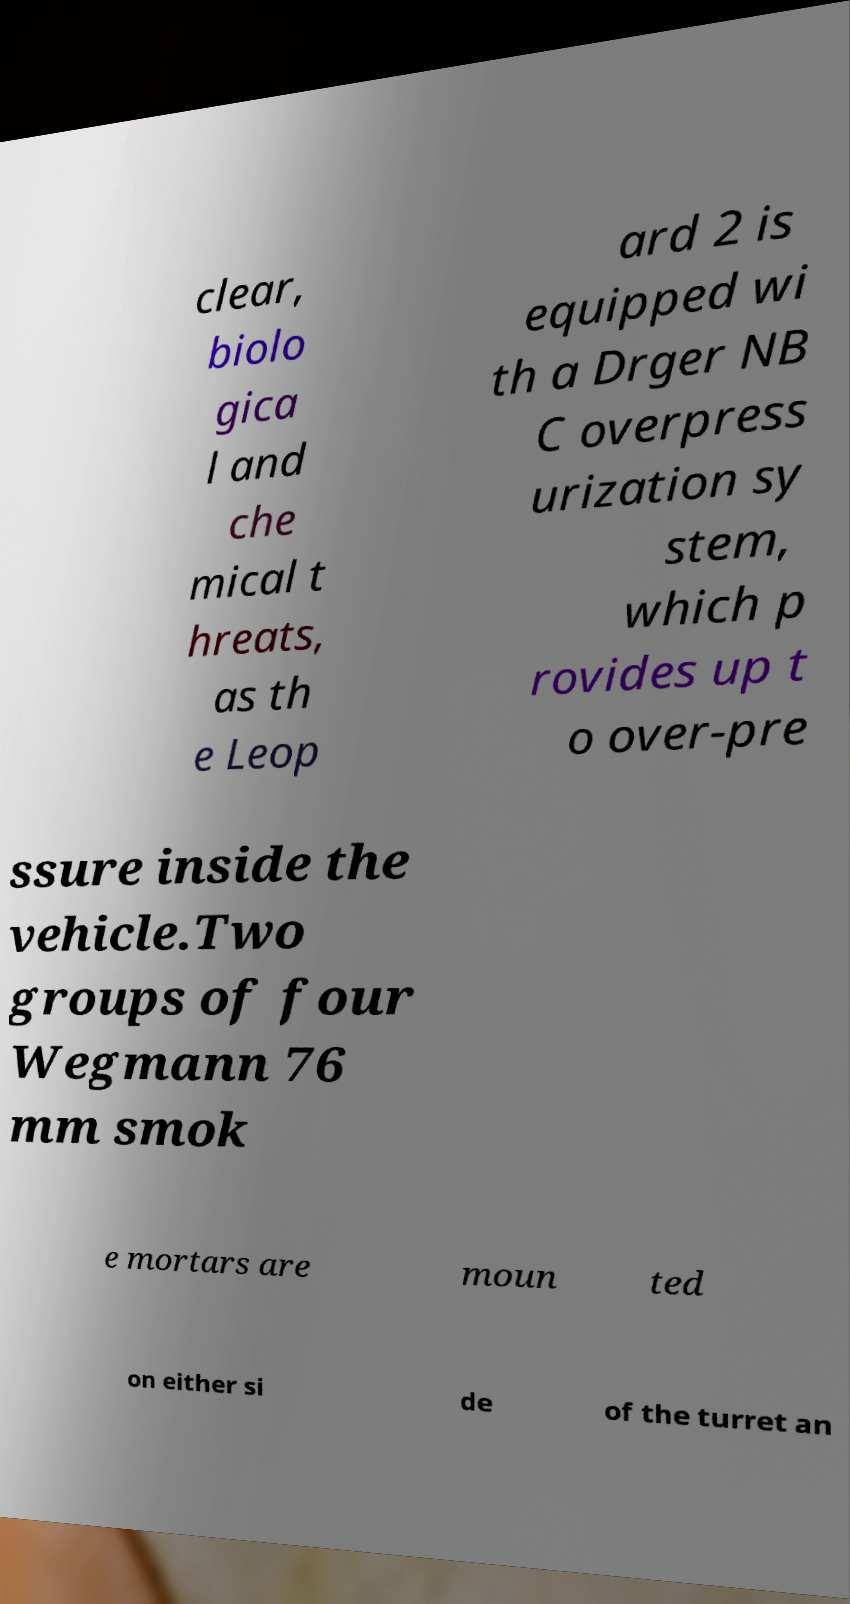Can you read and provide the text displayed in the image?This photo seems to have some interesting text. Can you extract and type it out for me? clear, biolo gica l and che mical t hreats, as th e Leop ard 2 is equipped wi th a Drger NB C overpress urization sy stem, which p rovides up t o over-pre ssure inside the vehicle.Two groups of four Wegmann 76 mm smok e mortars are moun ted on either si de of the turret an 